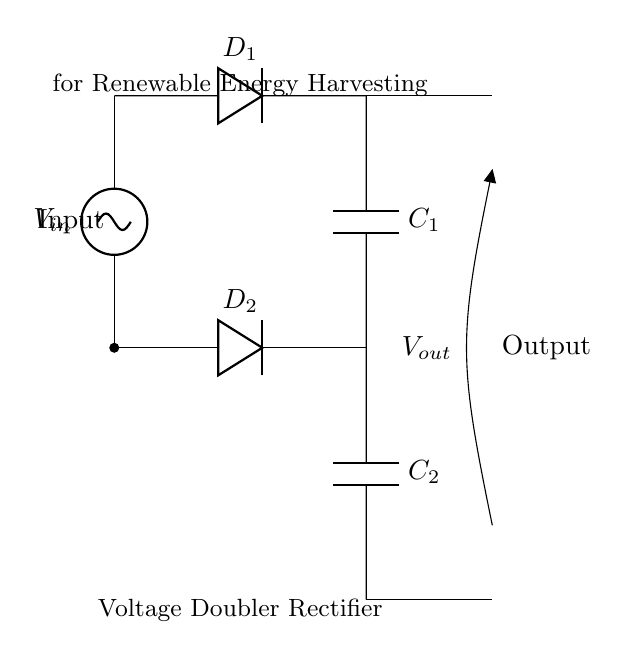What components are used in the circuit? The circuit uses two diodes (D1 and D2) and two capacitors (C1 and C2). This is evident from the labeled components in the diagram.
Answer: Two diodes and two capacitors What is the function of D1 in this circuit? D1 acts as a rectifier, allowing current to flow in only one direction and helping to charge capacitor C1 during the positive half-cycle of the input AC signal.
Answer: Rectifying What is the role of C2 in the voltage doubler circuit? C2 helps to increase the output voltage by storing charge during the negative half-cycle and releasing it during the positive half-cycle, effectively doubling the output voltage.
Answer: Voltage doubling How many output terminals are there in this circuit? There are two output terminals, one connected to the upper side of C1 and the other to the lower side of C2, which are both used to measure the output voltage.
Answer: Two In which application is this voltage doubler circuit commonly used? This circuit is often utilized in renewable energy harvesting applications, as indicated by the label in the diagram.
Answer: Renewable energy harvesting What voltage does the circuit aim to produce compared to the input voltage? The circuit aims to produce approximately double the input voltage, as it is designed as a voltage doubler rectifier circuit.
Answer: Double the input voltage 